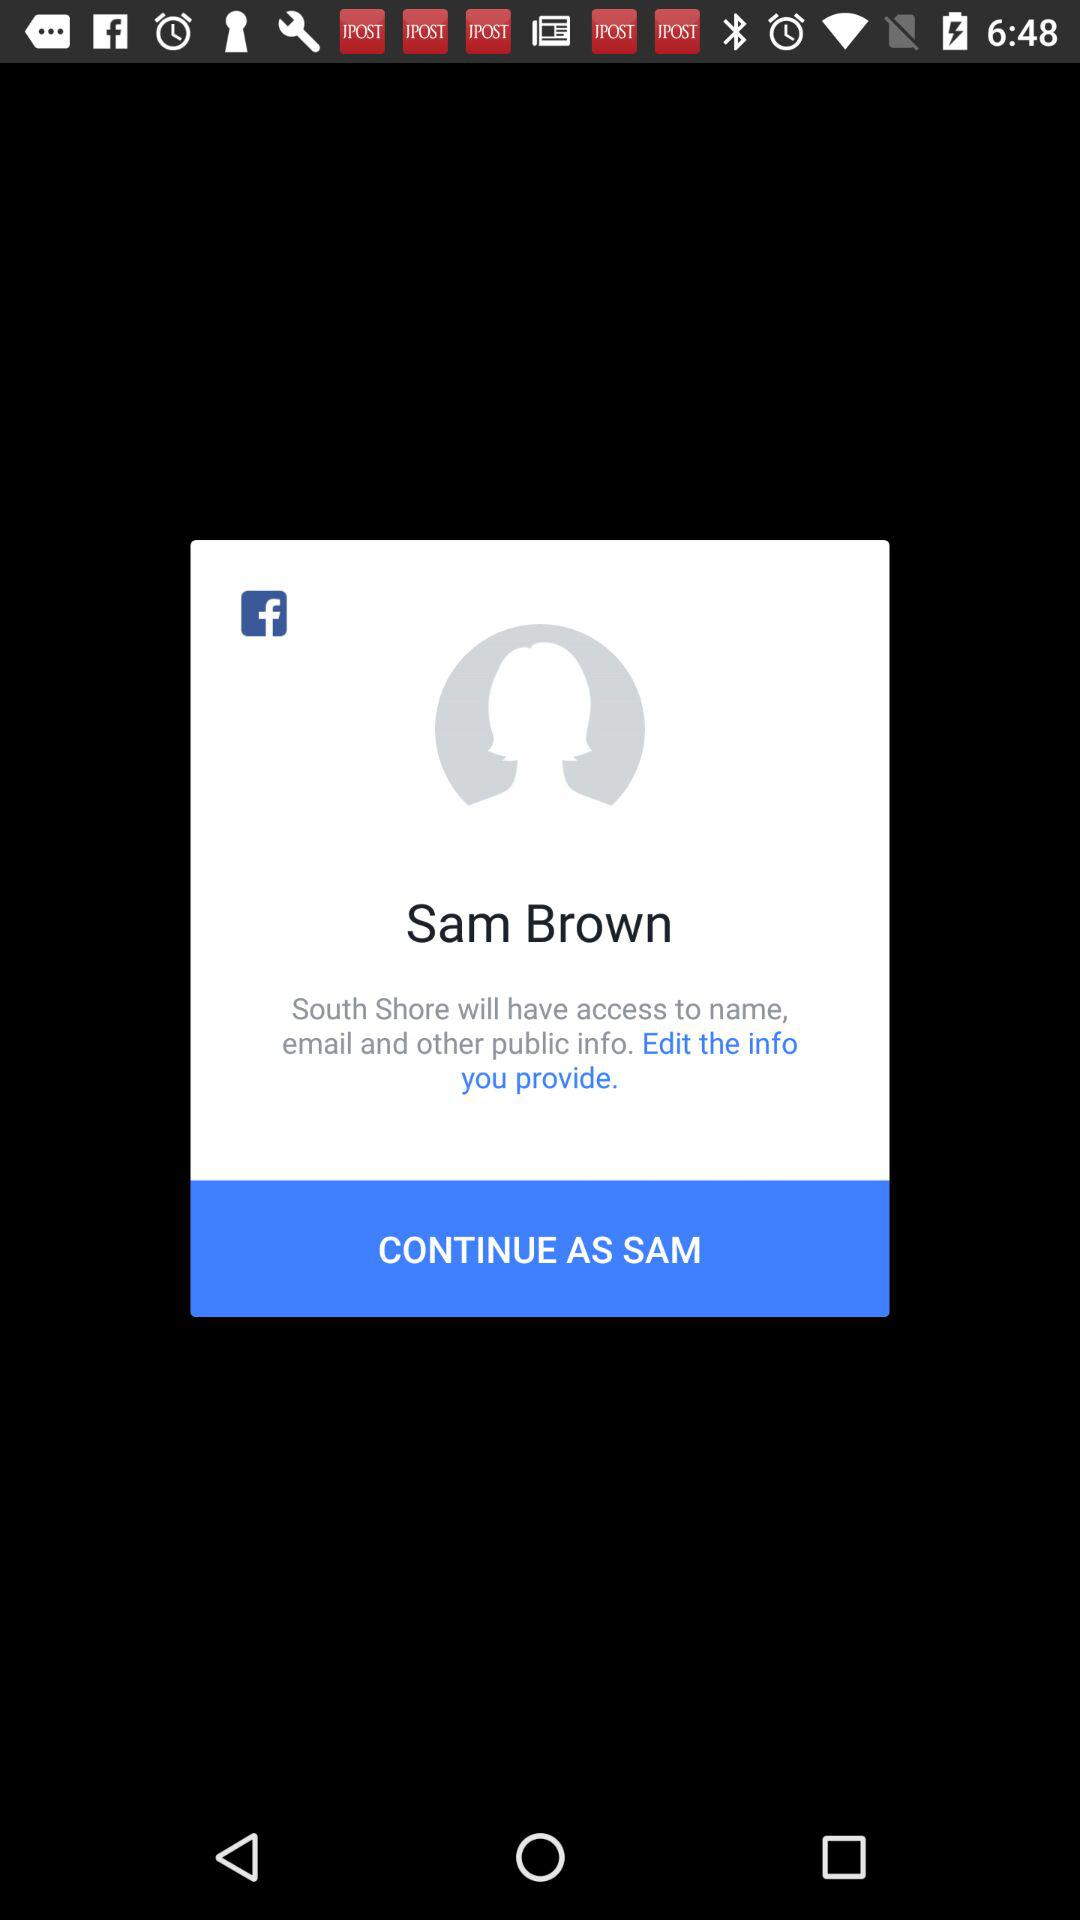What is the login name? The login name is Sam Brown. 